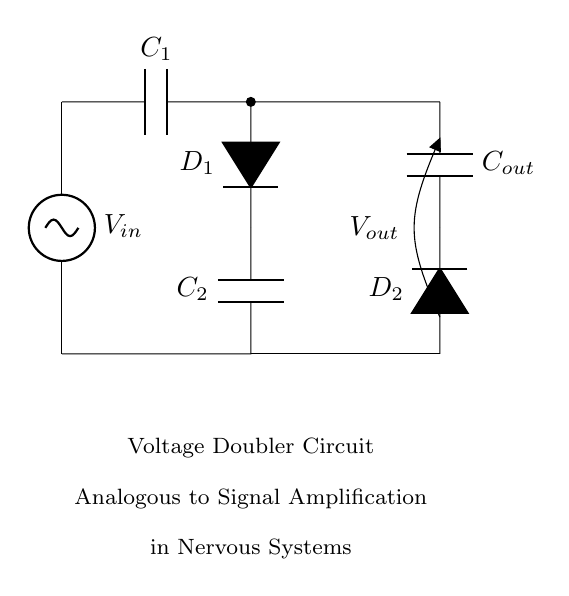What is the input voltage? The input voltage is denoted as V_in, located at the source on the left side of the circuit diagram.
Answer: V_in What type of circuit is depicted? The circuit is a voltage doubler, as indicated by the label in the diagram and its configuration of capacitors and diodes specialized for voltage multiplication.
Answer: Voltage doubler How many diodes are in the circuit? There are two diodes present in the circuit, labeled as D_1 and D_2 connecting the components.
Answer: Two How many capacitors are used? The circuit contains three capacitors, namely C_1, C_2, and C_out, as seen in the schematic.
Answer: Three What is the purpose of the capacitors in this circuit? The capacitors in the voltage doubler are used to store electrical energy and help in voltage multiplication by alternating their charging and discharging cycles.
Answer: Energy storage and voltage multiplication Why does this circuit amplify voltage? This circuit amplifies voltage by using diodes to allow current to flow in one direction combined with capacitors that charge and discharge, effectively doubling the output voltage based on the input.
Answer: Because of diode action and capacitive charging How does the behavior of the voltage doubler compare to sensory signal amplification in nervous systems? The voltage doubler amplifies electrical signals much like sensory neurons amplify stimuli into nerve impulses, enhancing the signal's strength before transmission, similar to the way this circuit increases output voltage.
Answer: Both enhance signal strength 